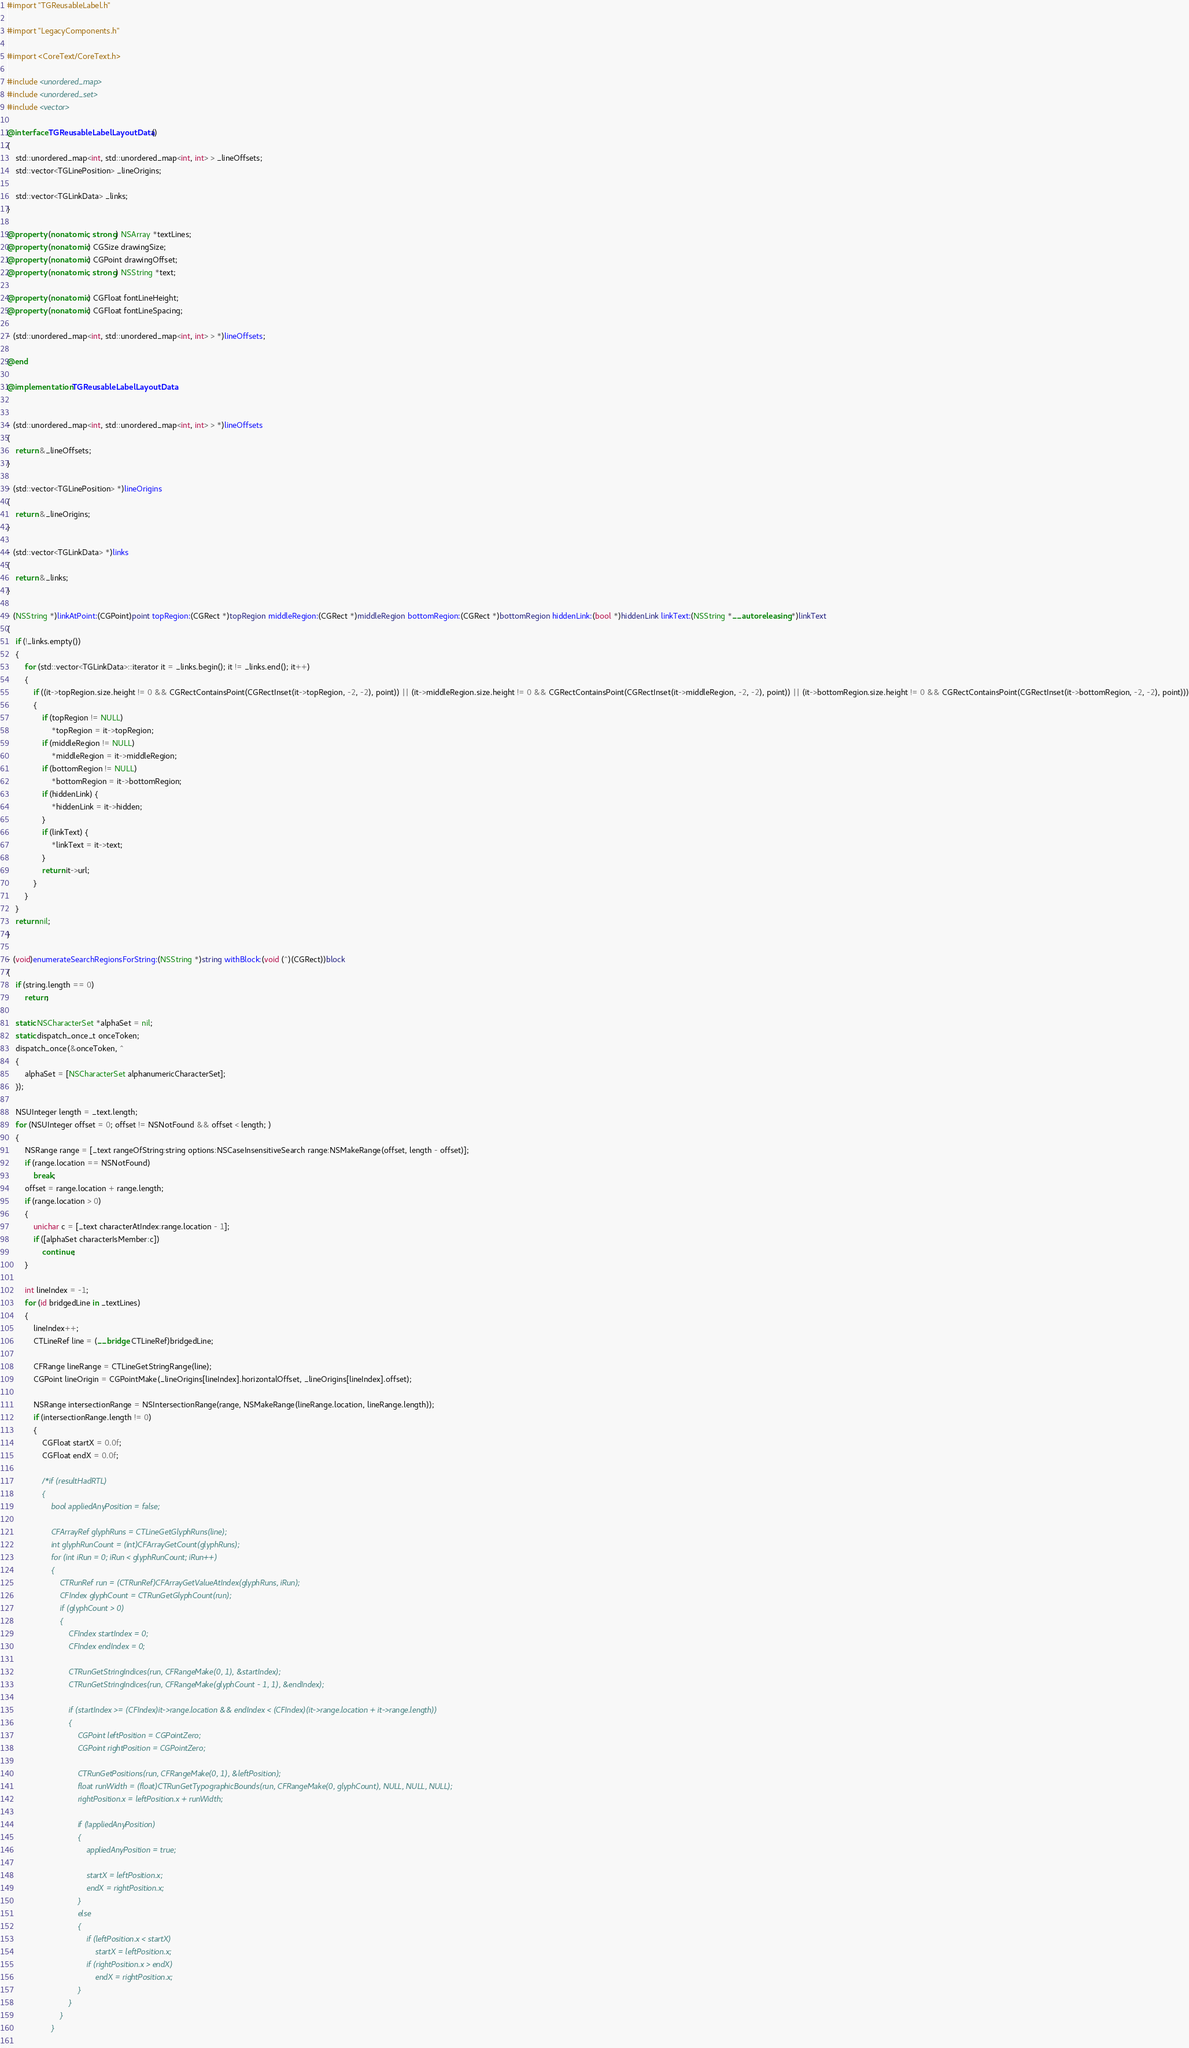<code> <loc_0><loc_0><loc_500><loc_500><_ObjectiveC_>#import "TGReusableLabel.h"

#import "LegacyComponents.h"

#import <CoreText/CoreText.h>

#include <unordered_map>
#include <unordered_set>
#include <vector>

@interface TGReusableLabelLayoutData ()
{
    std::unordered_map<int, std::unordered_map<int, int> > _lineOffsets;
    std::vector<TGLinePosition> _lineOrigins;
    
    std::vector<TGLinkData> _links;
}

@property (nonatomic, strong) NSArray *textLines;
@property (nonatomic) CGSize drawingSize;
@property (nonatomic) CGPoint drawingOffset;
@property (nonatomic, strong) NSString *text;

@property (nonatomic) CGFloat fontLineHeight;
@property (nonatomic) CGFloat fontLineSpacing;

- (std::unordered_map<int, std::unordered_map<int, int> > *)lineOffsets;

@end

@implementation TGReusableLabelLayoutData


- (std::unordered_map<int, std::unordered_map<int, int> > *)lineOffsets
{
    return &_lineOffsets;
}

- (std::vector<TGLinePosition> *)lineOrigins
{
    return &_lineOrigins;
}

- (std::vector<TGLinkData> *)links
{
    return &_links;
}

- (NSString *)linkAtPoint:(CGPoint)point topRegion:(CGRect *)topRegion middleRegion:(CGRect *)middleRegion bottomRegion:(CGRect *)bottomRegion hiddenLink:(bool *)hiddenLink linkText:(NSString *__autoreleasing *)linkText
{
    if (!_links.empty())
    {
        for (std::vector<TGLinkData>::iterator it = _links.begin(); it != _links.end(); it++)
        {
            if ((it->topRegion.size.height != 0 && CGRectContainsPoint(CGRectInset(it->topRegion, -2, -2), point)) || (it->middleRegion.size.height != 0 && CGRectContainsPoint(CGRectInset(it->middleRegion, -2, -2), point)) || (it->bottomRegion.size.height != 0 && CGRectContainsPoint(CGRectInset(it->bottomRegion, -2, -2), point)))
            {
                if (topRegion != NULL)
                    *topRegion = it->topRegion;
                if (middleRegion != NULL)
                    *middleRegion = it->middleRegion;
                if (bottomRegion != NULL)
                    *bottomRegion = it->bottomRegion;
                if (hiddenLink) {
                    *hiddenLink = it->hidden;
                }
                if (linkText) {
                    *linkText = it->text;
                }
                return it->url;
            }
        }
    }
    return nil;
}

- (void)enumerateSearchRegionsForString:(NSString *)string withBlock:(void (^)(CGRect))block
{
    if (string.length == 0)
        return;
    
    static NSCharacterSet *alphaSet = nil;
    static dispatch_once_t onceToken;
    dispatch_once(&onceToken, ^
    {
        alphaSet = [NSCharacterSet alphanumericCharacterSet];
    });
    
    NSUInteger length = _text.length;
    for (NSUInteger offset = 0; offset != NSNotFound && offset < length; )
    {
        NSRange range = [_text rangeOfString:string options:NSCaseInsensitiveSearch range:NSMakeRange(offset, length - offset)];
        if (range.location == NSNotFound)
            break;
        offset = range.location + range.length;
        if (range.location > 0)
        {
            unichar c = [_text characterAtIndex:range.location - 1];
            if ([alphaSet characterIsMember:c])
                continue;
        }
        
        int lineIndex = -1;
        for (id bridgedLine in _textLines)
        {
            lineIndex++;
            CTLineRef line = (__bridge CTLineRef)bridgedLine;
            
            CFRange lineRange = CTLineGetStringRange(line);
            CGPoint lineOrigin = CGPointMake(_lineOrigins[lineIndex].horizontalOffset, _lineOrigins[lineIndex].offset);
            
            NSRange intersectionRange = NSIntersectionRange(range, NSMakeRange(lineRange.location, lineRange.length));
            if (intersectionRange.length != 0)
            {
                CGFloat startX = 0.0f;
                CGFloat endX = 0.0f;
                
                /*if (resultHadRTL)
                {
                    bool appliedAnyPosition = false;
                    
                    CFArrayRef glyphRuns = CTLineGetGlyphRuns(line);
                    int glyphRunCount = (int)CFArrayGetCount(glyphRuns);
                    for (int iRun = 0; iRun < glyphRunCount; iRun++)
                    {
                        CTRunRef run = (CTRunRef)CFArrayGetValueAtIndex(glyphRuns, iRun);
                        CFIndex glyphCount = CTRunGetGlyphCount(run);
                        if (glyphCount > 0)
                        {
                            CFIndex startIndex = 0;
                            CFIndex endIndex = 0;
                            
                            CTRunGetStringIndices(run, CFRangeMake(0, 1), &startIndex);
                            CTRunGetStringIndices(run, CFRangeMake(glyphCount - 1, 1), &endIndex);
                            
                            if (startIndex >= (CFIndex)it->range.location && endIndex < (CFIndex)(it->range.location + it->range.length))
                            {
                                CGPoint leftPosition = CGPointZero;
                                CGPoint rightPosition = CGPointZero;
                                
                                CTRunGetPositions(run, CFRangeMake(0, 1), &leftPosition);
                                float runWidth = (float)CTRunGetTypographicBounds(run, CFRangeMake(0, glyphCount), NULL, NULL, NULL);
                                rightPosition.x = leftPosition.x + runWidth;
                                
                                if (!appliedAnyPosition)
                                {
                                    appliedAnyPosition = true;
                                    
                                    startX = leftPosition.x;
                                    endX = rightPosition.x;
                                }
                                else
                                {
                                    if (leftPosition.x < startX)
                                        startX = leftPosition.x;
                                    if (rightPosition.x > endX)
                                        endX = rightPosition.x;
                                }
                            }
                        }
                    }
                    </code> 